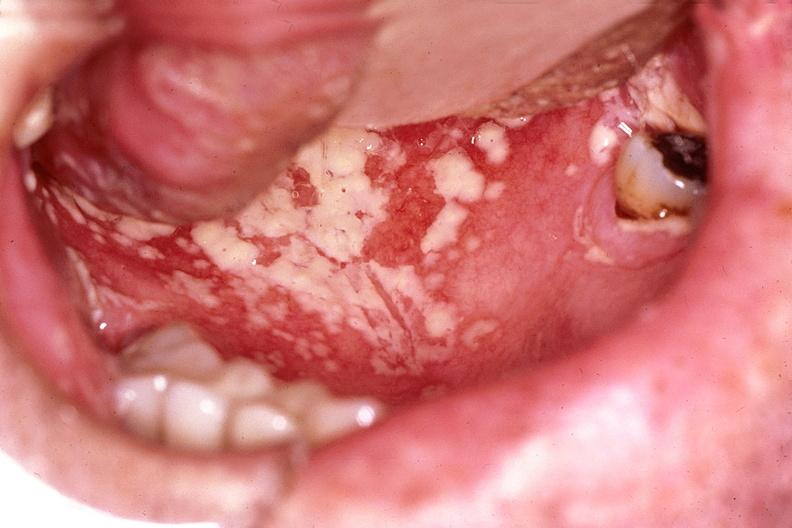what is present?
Answer the question using a single word or phrase. Gastrointestinal 